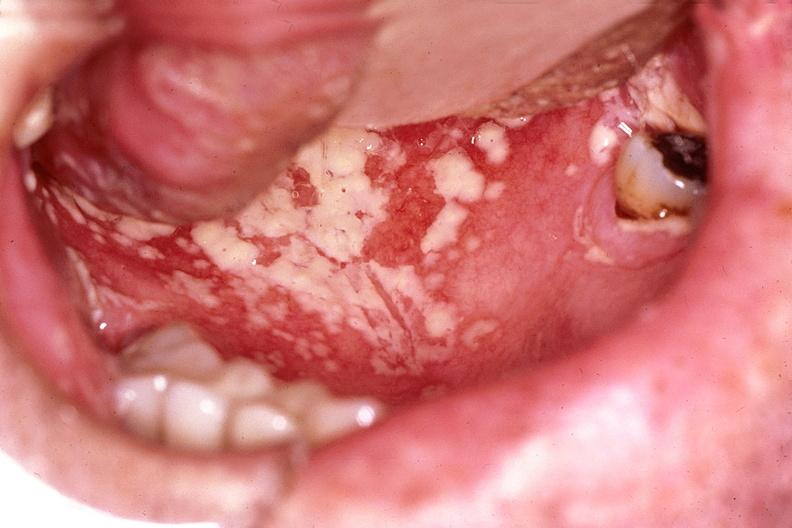what is present?
Answer the question using a single word or phrase. Gastrointestinal 